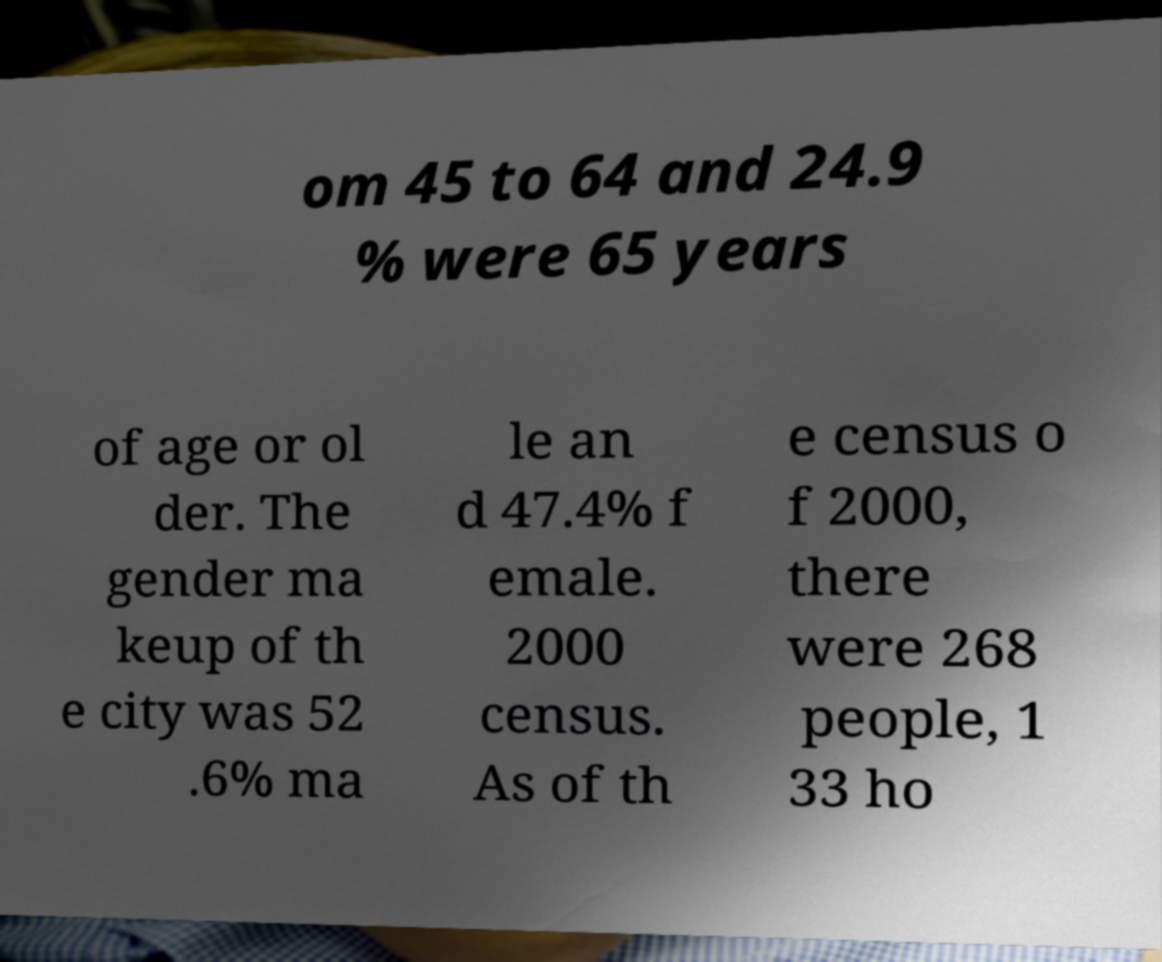There's text embedded in this image that I need extracted. Can you transcribe it verbatim? om 45 to 64 and 24.9 % were 65 years of age or ol der. The gender ma keup of th e city was 52 .6% ma le an d 47.4% f emale. 2000 census. As of th e census o f 2000, there were 268 people, 1 33 ho 